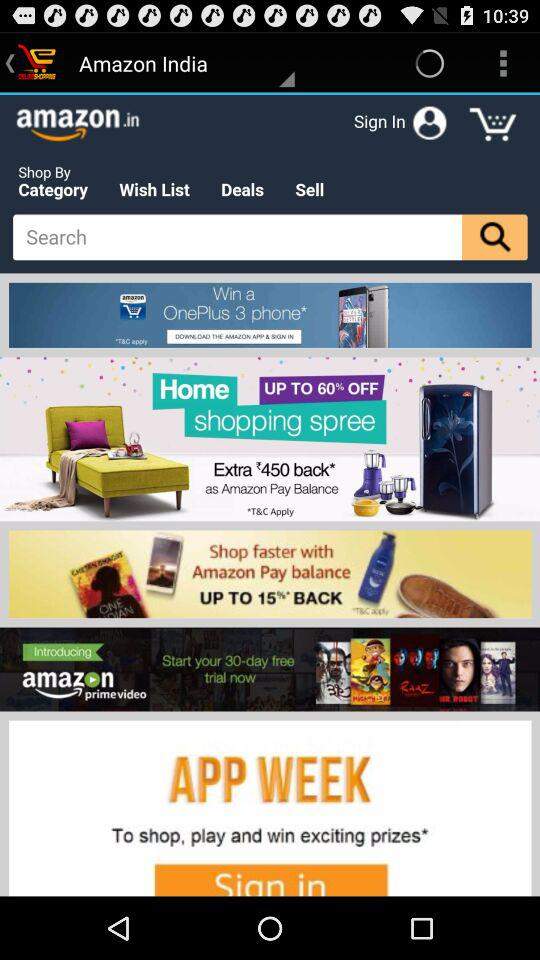What phone can I win? You can win OnePlus 3 phone. 